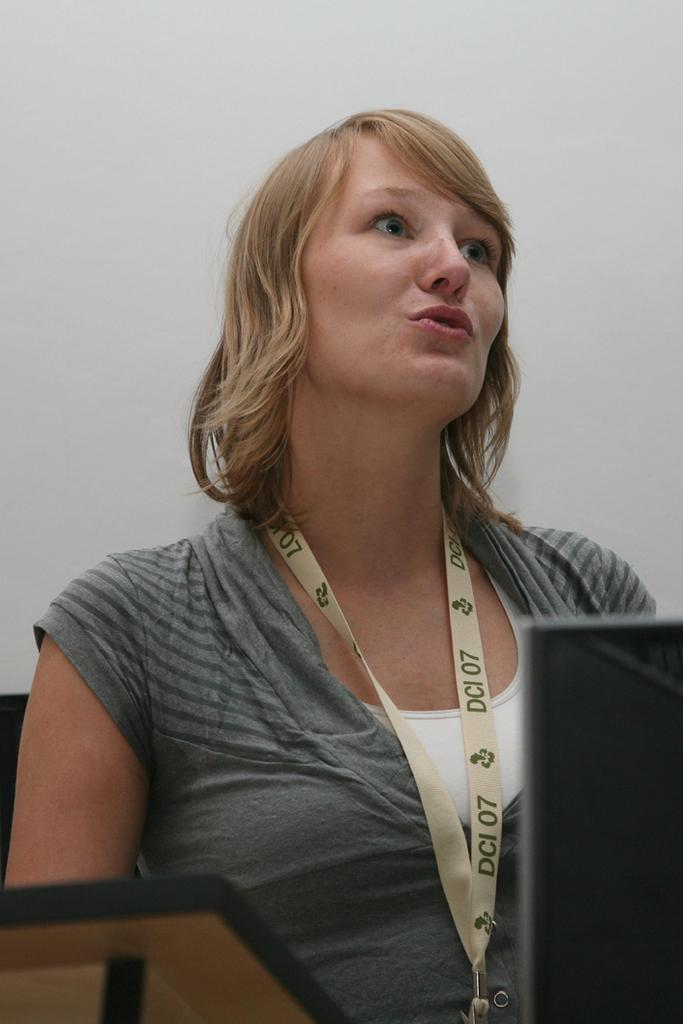Who is the main subject in the image? There is a woman standing in the center of the image. What is the woman wearing in the image? The woman is wearing an identity card. What can be seen in the bottom right corner of the image? There is a fountain in the bottom right corner of the image. What is visible in the background of the image? There is a wall in the background of the image. How does the woman say good-bye to the fountain in the image? There is no indication in the image that the woman is saying good-bye to the fountain, nor is there any interaction between them. 